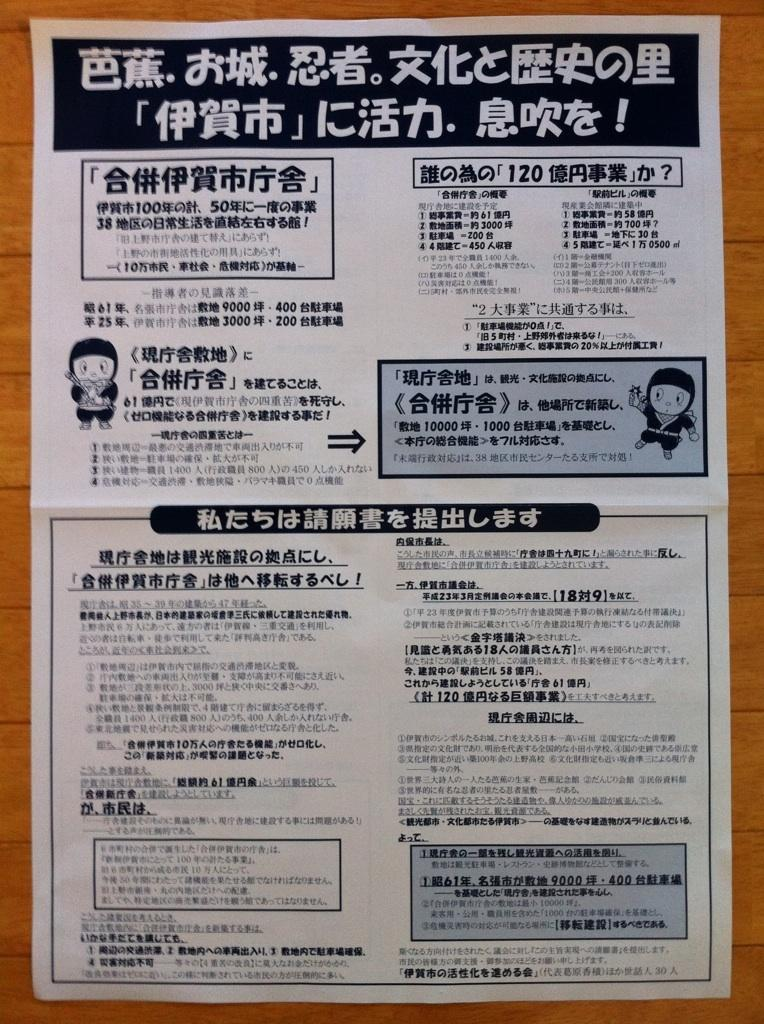What is on the paper that is visible in the image? The paper contains two cartoon pictures. What else can be seen on the paper besides the cartoon pictures? There is text on the paper. Where is the paper located in the image? The paper is on a table. How does the bomb explode in the image? There is no bomb present in the image; it only contains a paper with cartoon pictures and text. 